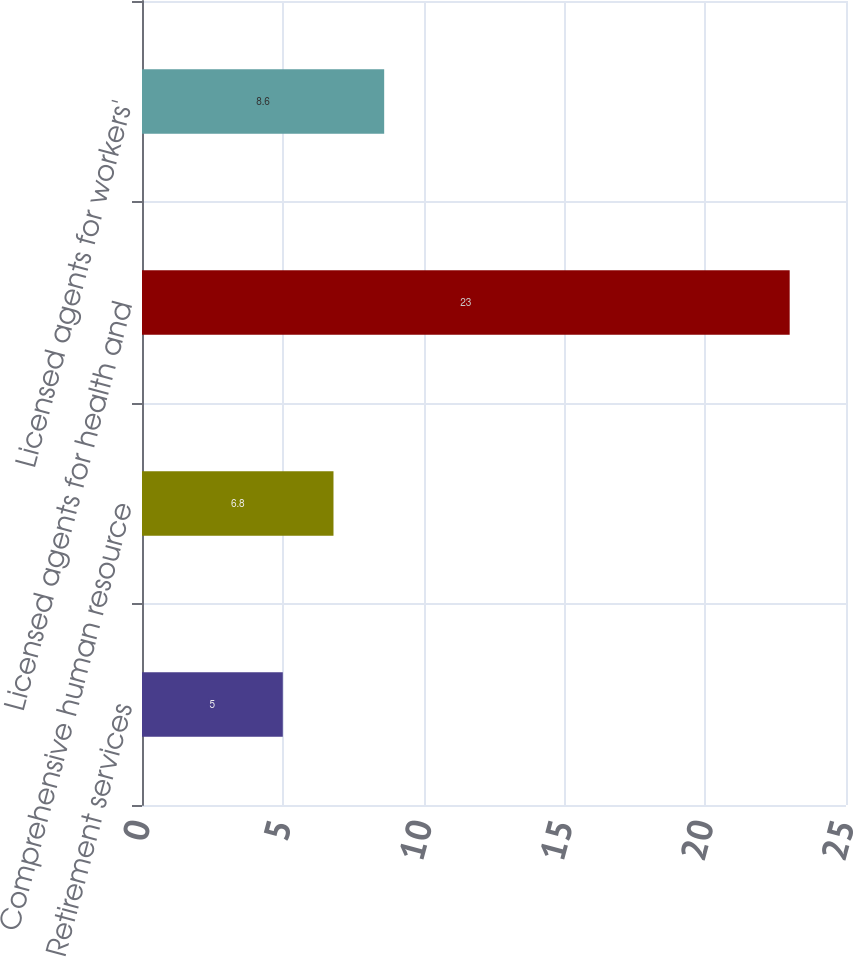<chart> <loc_0><loc_0><loc_500><loc_500><bar_chart><fcel>Retirement services<fcel>Comprehensive human resource<fcel>Licensed agents for health and<fcel>Licensed agents for workers'<nl><fcel>5<fcel>6.8<fcel>23<fcel>8.6<nl></chart> 